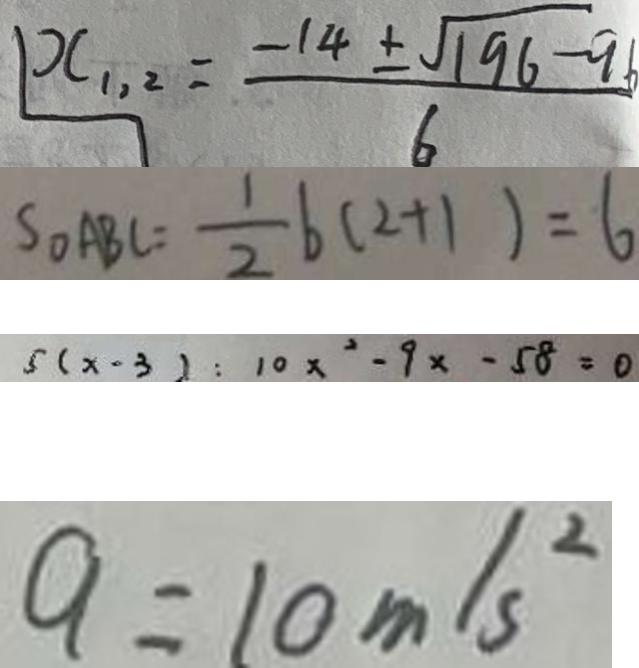Convert formula to latex. <formula><loc_0><loc_0><loc_500><loc_500>x _ { 1 , 2 } = \frac { - 1 4 \pm \sqrt { 1 9 6 - 9 6 } } { 6 } 
 S _ { \Delta A B C } = \frac { 1 } { 2 } b ( 2 + 1 ) = 6 
 5 ( x - 3 ) : 1 0 x ^ { 2 } - 9 x - 5 8 = 0 
 9 = 1 0 m / s ^ { 2 }</formula> 